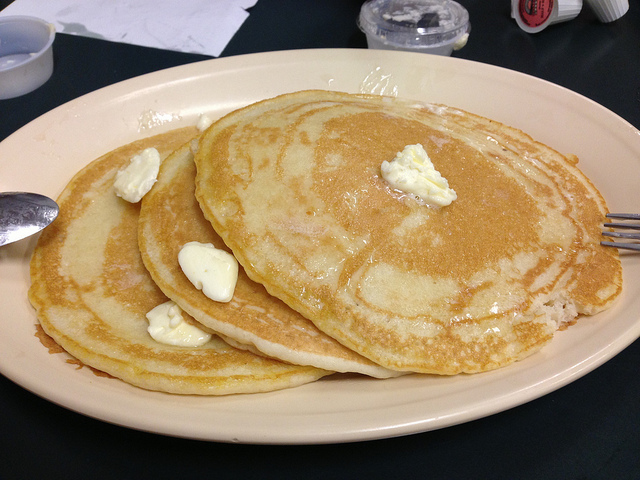<image>What restaurant is this at? I am not sure, but the restaurant could be IHOP or Pancake House. What restaurant is this at? I don't know what restaurant this is at. It can be IHOP or Pancake House. 